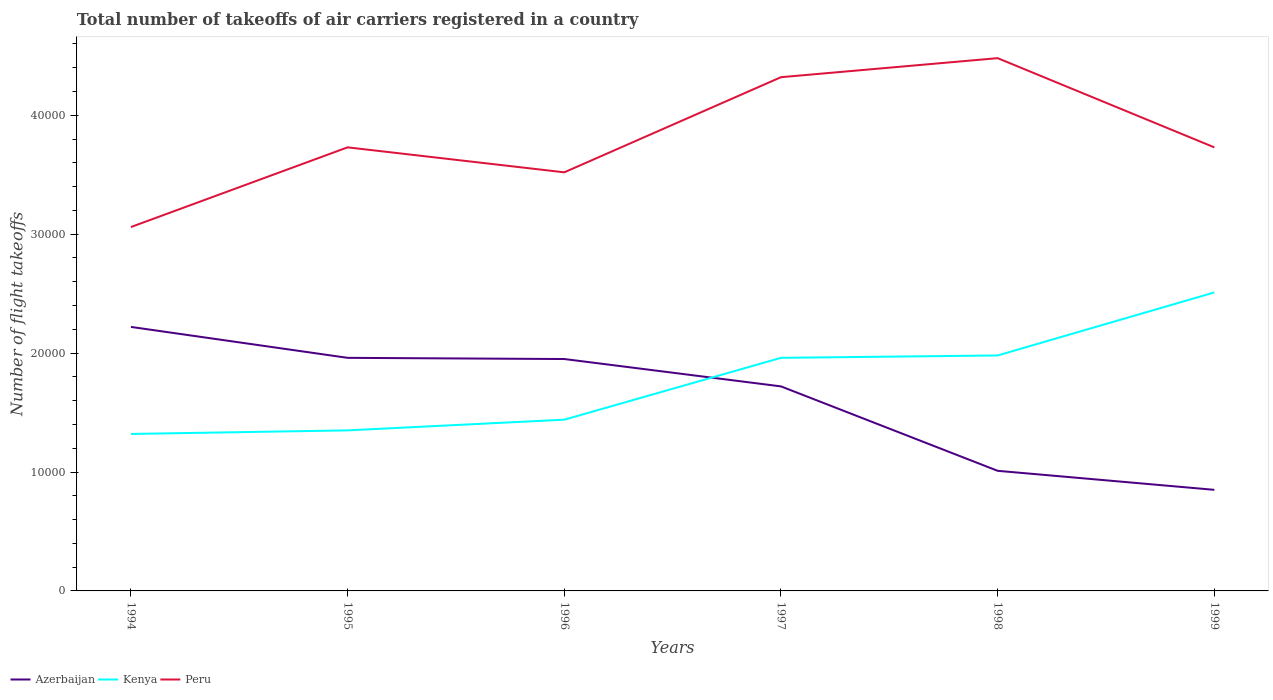Does the line corresponding to Azerbaijan intersect with the line corresponding to Kenya?
Ensure brevity in your answer.  Yes. Across all years, what is the maximum total number of flight takeoffs in Azerbaijan?
Offer a very short reply. 8500. What is the total total number of flight takeoffs in Kenya in the graph?
Ensure brevity in your answer.  -900. What is the difference between the highest and the second highest total number of flight takeoffs in Peru?
Keep it short and to the point. 1.42e+04. What is the difference between the highest and the lowest total number of flight takeoffs in Azerbaijan?
Your answer should be compact. 4. Is the total number of flight takeoffs in Azerbaijan strictly greater than the total number of flight takeoffs in Peru over the years?
Your answer should be compact. Yes. How many lines are there?
Your answer should be very brief. 3. How many years are there in the graph?
Your answer should be very brief. 6. Are the values on the major ticks of Y-axis written in scientific E-notation?
Offer a very short reply. No. What is the title of the graph?
Your response must be concise. Total number of takeoffs of air carriers registered in a country. Does "Montenegro" appear as one of the legend labels in the graph?
Your answer should be compact. No. What is the label or title of the Y-axis?
Your answer should be compact. Number of flight takeoffs. What is the Number of flight takeoffs in Azerbaijan in 1994?
Offer a very short reply. 2.22e+04. What is the Number of flight takeoffs in Kenya in 1994?
Your response must be concise. 1.32e+04. What is the Number of flight takeoffs in Peru in 1994?
Provide a succinct answer. 3.06e+04. What is the Number of flight takeoffs in Azerbaijan in 1995?
Your answer should be very brief. 1.96e+04. What is the Number of flight takeoffs in Kenya in 1995?
Your answer should be very brief. 1.35e+04. What is the Number of flight takeoffs of Peru in 1995?
Ensure brevity in your answer.  3.73e+04. What is the Number of flight takeoffs of Azerbaijan in 1996?
Keep it short and to the point. 1.95e+04. What is the Number of flight takeoffs of Kenya in 1996?
Make the answer very short. 1.44e+04. What is the Number of flight takeoffs of Peru in 1996?
Your response must be concise. 3.52e+04. What is the Number of flight takeoffs in Azerbaijan in 1997?
Your response must be concise. 1.72e+04. What is the Number of flight takeoffs of Kenya in 1997?
Keep it short and to the point. 1.96e+04. What is the Number of flight takeoffs in Peru in 1997?
Your response must be concise. 4.32e+04. What is the Number of flight takeoffs of Azerbaijan in 1998?
Ensure brevity in your answer.  1.01e+04. What is the Number of flight takeoffs in Kenya in 1998?
Your answer should be very brief. 1.98e+04. What is the Number of flight takeoffs in Peru in 1998?
Keep it short and to the point. 4.48e+04. What is the Number of flight takeoffs of Azerbaijan in 1999?
Offer a terse response. 8500. What is the Number of flight takeoffs in Kenya in 1999?
Ensure brevity in your answer.  2.51e+04. What is the Number of flight takeoffs of Peru in 1999?
Your response must be concise. 3.73e+04. Across all years, what is the maximum Number of flight takeoffs in Azerbaijan?
Give a very brief answer. 2.22e+04. Across all years, what is the maximum Number of flight takeoffs in Kenya?
Offer a terse response. 2.51e+04. Across all years, what is the maximum Number of flight takeoffs of Peru?
Your answer should be compact. 4.48e+04. Across all years, what is the minimum Number of flight takeoffs of Azerbaijan?
Ensure brevity in your answer.  8500. Across all years, what is the minimum Number of flight takeoffs of Kenya?
Your answer should be compact. 1.32e+04. Across all years, what is the minimum Number of flight takeoffs in Peru?
Provide a succinct answer. 3.06e+04. What is the total Number of flight takeoffs of Azerbaijan in the graph?
Provide a short and direct response. 9.71e+04. What is the total Number of flight takeoffs in Kenya in the graph?
Your response must be concise. 1.06e+05. What is the total Number of flight takeoffs in Peru in the graph?
Your answer should be very brief. 2.28e+05. What is the difference between the Number of flight takeoffs of Azerbaijan in 1994 and that in 1995?
Ensure brevity in your answer.  2600. What is the difference between the Number of flight takeoffs of Kenya in 1994 and that in 1995?
Make the answer very short. -300. What is the difference between the Number of flight takeoffs of Peru in 1994 and that in 1995?
Offer a very short reply. -6700. What is the difference between the Number of flight takeoffs in Azerbaijan in 1994 and that in 1996?
Offer a very short reply. 2700. What is the difference between the Number of flight takeoffs of Kenya in 1994 and that in 1996?
Your response must be concise. -1200. What is the difference between the Number of flight takeoffs of Peru in 1994 and that in 1996?
Your answer should be very brief. -4600. What is the difference between the Number of flight takeoffs in Kenya in 1994 and that in 1997?
Ensure brevity in your answer.  -6400. What is the difference between the Number of flight takeoffs in Peru in 1994 and that in 1997?
Your response must be concise. -1.26e+04. What is the difference between the Number of flight takeoffs of Azerbaijan in 1994 and that in 1998?
Keep it short and to the point. 1.21e+04. What is the difference between the Number of flight takeoffs of Kenya in 1994 and that in 1998?
Provide a short and direct response. -6600. What is the difference between the Number of flight takeoffs in Peru in 1994 and that in 1998?
Keep it short and to the point. -1.42e+04. What is the difference between the Number of flight takeoffs of Azerbaijan in 1994 and that in 1999?
Offer a very short reply. 1.37e+04. What is the difference between the Number of flight takeoffs of Kenya in 1994 and that in 1999?
Make the answer very short. -1.19e+04. What is the difference between the Number of flight takeoffs of Peru in 1994 and that in 1999?
Give a very brief answer. -6700. What is the difference between the Number of flight takeoffs in Kenya in 1995 and that in 1996?
Offer a terse response. -900. What is the difference between the Number of flight takeoffs of Peru in 1995 and that in 1996?
Provide a short and direct response. 2100. What is the difference between the Number of flight takeoffs in Azerbaijan in 1995 and that in 1997?
Your answer should be very brief. 2400. What is the difference between the Number of flight takeoffs in Kenya in 1995 and that in 1997?
Offer a terse response. -6100. What is the difference between the Number of flight takeoffs of Peru in 1995 and that in 1997?
Your response must be concise. -5900. What is the difference between the Number of flight takeoffs of Azerbaijan in 1995 and that in 1998?
Offer a terse response. 9500. What is the difference between the Number of flight takeoffs of Kenya in 1995 and that in 1998?
Offer a terse response. -6300. What is the difference between the Number of flight takeoffs of Peru in 1995 and that in 1998?
Offer a terse response. -7500. What is the difference between the Number of flight takeoffs of Azerbaijan in 1995 and that in 1999?
Make the answer very short. 1.11e+04. What is the difference between the Number of flight takeoffs of Kenya in 1995 and that in 1999?
Offer a very short reply. -1.16e+04. What is the difference between the Number of flight takeoffs in Peru in 1995 and that in 1999?
Your response must be concise. 0. What is the difference between the Number of flight takeoffs of Azerbaijan in 1996 and that in 1997?
Keep it short and to the point. 2300. What is the difference between the Number of flight takeoffs of Kenya in 1996 and that in 1997?
Provide a succinct answer. -5200. What is the difference between the Number of flight takeoffs in Peru in 1996 and that in 1997?
Provide a succinct answer. -8000. What is the difference between the Number of flight takeoffs of Azerbaijan in 1996 and that in 1998?
Your answer should be very brief. 9400. What is the difference between the Number of flight takeoffs of Kenya in 1996 and that in 1998?
Give a very brief answer. -5400. What is the difference between the Number of flight takeoffs of Peru in 1996 and that in 1998?
Your response must be concise. -9600. What is the difference between the Number of flight takeoffs in Azerbaijan in 1996 and that in 1999?
Provide a short and direct response. 1.10e+04. What is the difference between the Number of flight takeoffs of Kenya in 1996 and that in 1999?
Keep it short and to the point. -1.07e+04. What is the difference between the Number of flight takeoffs in Peru in 1996 and that in 1999?
Provide a succinct answer. -2100. What is the difference between the Number of flight takeoffs in Azerbaijan in 1997 and that in 1998?
Ensure brevity in your answer.  7100. What is the difference between the Number of flight takeoffs of Kenya in 1997 and that in 1998?
Your answer should be compact. -200. What is the difference between the Number of flight takeoffs of Peru in 1997 and that in 1998?
Offer a terse response. -1600. What is the difference between the Number of flight takeoffs of Azerbaijan in 1997 and that in 1999?
Give a very brief answer. 8700. What is the difference between the Number of flight takeoffs in Kenya in 1997 and that in 1999?
Provide a short and direct response. -5500. What is the difference between the Number of flight takeoffs in Peru in 1997 and that in 1999?
Make the answer very short. 5900. What is the difference between the Number of flight takeoffs in Azerbaijan in 1998 and that in 1999?
Your answer should be compact. 1600. What is the difference between the Number of flight takeoffs in Kenya in 1998 and that in 1999?
Give a very brief answer. -5300. What is the difference between the Number of flight takeoffs of Peru in 1998 and that in 1999?
Provide a short and direct response. 7500. What is the difference between the Number of flight takeoffs of Azerbaijan in 1994 and the Number of flight takeoffs of Kenya in 1995?
Your answer should be very brief. 8700. What is the difference between the Number of flight takeoffs of Azerbaijan in 1994 and the Number of flight takeoffs of Peru in 1995?
Offer a very short reply. -1.51e+04. What is the difference between the Number of flight takeoffs of Kenya in 1994 and the Number of flight takeoffs of Peru in 1995?
Offer a very short reply. -2.41e+04. What is the difference between the Number of flight takeoffs in Azerbaijan in 1994 and the Number of flight takeoffs in Kenya in 1996?
Keep it short and to the point. 7800. What is the difference between the Number of flight takeoffs of Azerbaijan in 1994 and the Number of flight takeoffs of Peru in 1996?
Your response must be concise. -1.30e+04. What is the difference between the Number of flight takeoffs in Kenya in 1994 and the Number of flight takeoffs in Peru in 1996?
Keep it short and to the point. -2.20e+04. What is the difference between the Number of flight takeoffs of Azerbaijan in 1994 and the Number of flight takeoffs of Kenya in 1997?
Ensure brevity in your answer.  2600. What is the difference between the Number of flight takeoffs of Azerbaijan in 1994 and the Number of flight takeoffs of Peru in 1997?
Ensure brevity in your answer.  -2.10e+04. What is the difference between the Number of flight takeoffs in Kenya in 1994 and the Number of flight takeoffs in Peru in 1997?
Provide a succinct answer. -3.00e+04. What is the difference between the Number of flight takeoffs in Azerbaijan in 1994 and the Number of flight takeoffs in Kenya in 1998?
Provide a short and direct response. 2400. What is the difference between the Number of flight takeoffs of Azerbaijan in 1994 and the Number of flight takeoffs of Peru in 1998?
Ensure brevity in your answer.  -2.26e+04. What is the difference between the Number of flight takeoffs in Kenya in 1994 and the Number of flight takeoffs in Peru in 1998?
Provide a succinct answer. -3.16e+04. What is the difference between the Number of flight takeoffs of Azerbaijan in 1994 and the Number of flight takeoffs of Kenya in 1999?
Your answer should be very brief. -2900. What is the difference between the Number of flight takeoffs in Azerbaijan in 1994 and the Number of flight takeoffs in Peru in 1999?
Keep it short and to the point. -1.51e+04. What is the difference between the Number of flight takeoffs in Kenya in 1994 and the Number of flight takeoffs in Peru in 1999?
Provide a succinct answer. -2.41e+04. What is the difference between the Number of flight takeoffs in Azerbaijan in 1995 and the Number of flight takeoffs in Kenya in 1996?
Ensure brevity in your answer.  5200. What is the difference between the Number of flight takeoffs in Azerbaijan in 1995 and the Number of flight takeoffs in Peru in 1996?
Your answer should be compact. -1.56e+04. What is the difference between the Number of flight takeoffs of Kenya in 1995 and the Number of flight takeoffs of Peru in 1996?
Keep it short and to the point. -2.17e+04. What is the difference between the Number of flight takeoffs of Azerbaijan in 1995 and the Number of flight takeoffs of Peru in 1997?
Your answer should be very brief. -2.36e+04. What is the difference between the Number of flight takeoffs in Kenya in 1995 and the Number of flight takeoffs in Peru in 1997?
Keep it short and to the point. -2.97e+04. What is the difference between the Number of flight takeoffs in Azerbaijan in 1995 and the Number of flight takeoffs in Kenya in 1998?
Offer a terse response. -200. What is the difference between the Number of flight takeoffs in Azerbaijan in 1995 and the Number of flight takeoffs in Peru in 1998?
Give a very brief answer. -2.52e+04. What is the difference between the Number of flight takeoffs in Kenya in 1995 and the Number of flight takeoffs in Peru in 1998?
Offer a terse response. -3.13e+04. What is the difference between the Number of flight takeoffs in Azerbaijan in 1995 and the Number of flight takeoffs in Kenya in 1999?
Make the answer very short. -5500. What is the difference between the Number of flight takeoffs of Azerbaijan in 1995 and the Number of flight takeoffs of Peru in 1999?
Your response must be concise. -1.77e+04. What is the difference between the Number of flight takeoffs of Kenya in 1995 and the Number of flight takeoffs of Peru in 1999?
Offer a very short reply. -2.38e+04. What is the difference between the Number of flight takeoffs of Azerbaijan in 1996 and the Number of flight takeoffs of Kenya in 1997?
Ensure brevity in your answer.  -100. What is the difference between the Number of flight takeoffs of Azerbaijan in 1996 and the Number of flight takeoffs of Peru in 1997?
Make the answer very short. -2.37e+04. What is the difference between the Number of flight takeoffs of Kenya in 1996 and the Number of flight takeoffs of Peru in 1997?
Your response must be concise. -2.88e+04. What is the difference between the Number of flight takeoffs in Azerbaijan in 1996 and the Number of flight takeoffs in Kenya in 1998?
Offer a very short reply. -300. What is the difference between the Number of flight takeoffs of Azerbaijan in 1996 and the Number of flight takeoffs of Peru in 1998?
Your response must be concise. -2.53e+04. What is the difference between the Number of flight takeoffs of Kenya in 1996 and the Number of flight takeoffs of Peru in 1998?
Provide a short and direct response. -3.04e+04. What is the difference between the Number of flight takeoffs of Azerbaijan in 1996 and the Number of flight takeoffs of Kenya in 1999?
Your response must be concise. -5600. What is the difference between the Number of flight takeoffs in Azerbaijan in 1996 and the Number of flight takeoffs in Peru in 1999?
Offer a terse response. -1.78e+04. What is the difference between the Number of flight takeoffs of Kenya in 1996 and the Number of flight takeoffs of Peru in 1999?
Provide a short and direct response. -2.29e+04. What is the difference between the Number of flight takeoffs in Azerbaijan in 1997 and the Number of flight takeoffs in Kenya in 1998?
Your answer should be very brief. -2600. What is the difference between the Number of flight takeoffs of Azerbaijan in 1997 and the Number of flight takeoffs of Peru in 1998?
Give a very brief answer. -2.76e+04. What is the difference between the Number of flight takeoffs of Kenya in 1997 and the Number of flight takeoffs of Peru in 1998?
Give a very brief answer. -2.52e+04. What is the difference between the Number of flight takeoffs in Azerbaijan in 1997 and the Number of flight takeoffs in Kenya in 1999?
Make the answer very short. -7900. What is the difference between the Number of flight takeoffs in Azerbaijan in 1997 and the Number of flight takeoffs in Peru in 1999?
Make the answer very short. -2.01e+04. What is the difference between the Number of flight takeoffs in Kenya in 1997 and the Number of flight takeoffs in Peru in 1999?
Keep it short and to the point. -1.77e+04. What is the difference between the Number of flight takeoffs of Azerbaijan in 1998 and the Number of flight takeoffs of Kenya in 1999?
Your answer should be very brief. -1.50e+04. What is the difference between the Number of flight takeoffs in Azerbaijan in 1998 and the Number of flight takeoffs in Peru in 1999?
Your answer should be very brief. -2.72e+04. What is the difference between the Number of flight takeoffs in Kenya in 1998 and the Number of flight takeoffs in Peru in 1999?
Your response must be concise. -1.75e+04. What is the average Number of flight takeoffs of Azerbaijan per year?
Your response must be concise. 1.62e+04. What is the average Number of flight takeoffs in Kenya per year?
Provide a succinct answer. 1.76e+04. What is the average Number of flight takeoffs of Peru per year?
Your answer should be compact. 3.81e+04. In the year 1994, what is the difference between the Number of flight takeoffs in Azerbaijan and Number of flight takeoffs in Kenya?
Give a very brief answer. 9000. In the year 1994, what is the difference between the Number of flight takeoffs in Azerbaijan and Number of flight takeoffs in Peru?
Your answer should be very brief. -8400. In the year 1994, what is the difference between the Number of flight takeoffs of Kenya and Number of flight takeoffs of Peru?
Offer a terse response. -1.74e+04. In the year 1995, what is the difference between the Number of flight takeoffs in Azerbaijan and Number of flight takeoffs in Kenya?
Offer a terse response. 6100. In the year 1995, what is the difference between the Number of flight takeoffs of Azerbaijan and Number of flight takeoffs of Peru?
Provide a succinct answer. -1.77e+04. In the year 1995, what is the difference between the Number of flight takeoffs in Kenya and Number of flight takeoffs in Peru?
Your response must be concise. -2.38e+04. In the year 1996, what is the difference between the Number of flight takeoffs of Azerbaijan and Number of flight takeoffs of Kenya?
Your answer should be very brief. 5100. In the year 1996, what is the difference between the Number of flight takeoffs in Azerbaijan and Number of flight takeoffs in Peru?
Your answer should be compact. -1.57e+04. In the year 1996, what is the difference between the Number of flight takeoffs of Kenya and Number of flight takeoffs of Peru?
Ensure brevity in your answer.  -2.08e+04. In the year 1997, what is the difference between the Number of flight takeoffs in Azerbaijan and Number of flight takeoffs in Kenya?
Keep it short and to the point. -2400. In the year 1997, what is the difference between the Number of flight takeoffs of Azerbaijan and Number of flight takeoffs of Peru?
Your response must be concise. -2.60e+04. In the year 1997, what is the difference between the Number of flight takeoffs in Kenya and Number of flight takeoffs in Peru?
Provide a succinct answer. -2.36e+04. In the year 1998, what is the difference between the Number of flight takeoffs of Azerbaijan and Number of flight takeoffs of Kenya?
Ensure brevity in your answer.  -9700. In the year 1998, what is the difference between the Number of flight takeoffs in Azerbaijan and Number of flight takeoffs in Peru?
Offer a very short reply. -3.47e+04. In the year 1998, what is the difference between the Number of flight takeoffs of Kenya and Number of flight takeoffs of Peru?
Ensure brevity in your answer.  -2.50e+04. In the year 1999, what is the difference between the Number of flight takeoffs in Azerbaijan and Number of flight takeoffs in Kenya?
Your answer should be compact. -1.66e+04. In the year 1999, what is the difference between the Number of flight takeoffs in Azerbaijan and Number of flight takeoffs in Peru?
Offer a terse response. -2.88e+04. In the year 1999, what is the difference between the Number of flight takeoffs in Kenya and Number of flight takeoffs in Peru?
Offer a terse response. -1.22e+04. What is the ratio of the Number of flight takeoffs of Azerbaijan in 1994 to that in 1995?
Provide a short and direct response. 1.13. What is the ratio of the Number of flight takeoffs in Kenya in 1994 to that in 1995?
Your answer should be very brief. 0.98. What is the ratio of the Number of flight takeoffs in Peru in 1994 to that in 1995?
Your answer should be compact. 0.82. What is the ratio of the Number of flight takeoffs in Azerbaijan in 1994 to that in 1996?
Provide a succinct answer. 1.14. What is the ratio of the Number of flight takeoffs of Peru in 1994 to that in 1996?
Offer a terse response. 0.87. What is the ratio of the Number of flight takeoffs of Azerbaijan in 1994 to that in 1997?
Keep it short and to the point. 1.29. What is the ratio of the Number of flight takeoffs in Kenya in 1994 to that in 1997?
Offer a terse response. 0.67. What is the ratio of the Number of flight takeoffs in Peru in 1994 to that in 1997?
Keep it short and to the point. 0.71. What is the ratio of the Number of flight takeoffs of Azerbaijan in 1994 to that in 1998?
Provide a succinct answer. 2.2. What is the ratio of the Number of flight takeoffs in Kenya in 1994 to that in 1998?
Keep it short and to the point. 0.67. What is the ratio of the Number of flight takeoffs of Peru in 1994 to that in 1998?
Your answer should be compact. 0.68. What is the ratio of the Number of flight takeoffs in Azerbaijan in 1994 to that in 1999?
Keep it short and to the point. 2.61. What is the ratio of the Number of flight takeoffs of Kenya in 1994 to that in 1999?
Your answer should be compact. 0.53. What is the ratio of the Number of flight takeoffs of Peru in 1994 to that in 1999?
Keep it short and to the point. 0.82. What is the ratio of the Number of flight takeoffs in Peru in 1995 to that in 1996?
Your response must be concise. 1.06. What is the ratio of the Number of flight takeoffs of Azerbaijan in 1995 to that in 1997?
Provide a short and direct response. 1.14. What is the ratio of the Number of flight takeoffs in Kenya in 1995 to that in 1997?
Provide a succinct answer. 0.69. What is the ratio of the Number of flight takeoffs of Peru in 1995 to that in 1997?
Your answer should be very brief. 0.86. What is the ratio of the Number of flight takeoffs of Azerbaijan in 1995 to that in 1998?
Ensure brevity in your answer.  1.94. What is the ratio of the Number of flight takeoffs of Kenya in 1995 to that in 1998?
Make the answer very short. 0.68. What is the ratio of the Number of flight takeoffs in Peru in 1995 to that in 1998?
Provide a short and direct response. 0.83. What is the ratio of the Number of flight takeoffs of Azerbaijan in 1995 to that in 1999?
Make the answer very short. 2.31. What is the ratio of the Number of flight takeoffs in Kenya in 1995 to that in 1999?
Offer a very short reply. 0.54. What is the ratio of the Number of flight takeoffs of Peru in 1995 to that in 1999?
Provide a succinct answer. 1. What is the ratio of the Number of flight takeoffs of Azerbaijan in 1996 to that in 1997?
Give a very brief answer. 1.13. What is the ratio of the Number of flight takeoffs in Kenya in 1996 to that in 1997?
Your response must be concise. 0.73. What is the ratio of the Number of flight takeoffs of Peru in 1996 to that in 1997?
Your answer should be very brief. 0.81. What is the ratio of the Number of flight takeoffs in Azerbaijan in 1996 to that in 1998?
Your response must be concise. 1.93. What is the ratio of the Number of flight takeoffs of Kenya in 1996 to that in 1998?
Offer a very short reply. 0.73. What is the ratio of the Number of flight takeoffs of Peru in 1996 to that in 1998?
Ensure brevity in your answer.  0.79. What is the ratio of the Number of flight takeoffs in Azerbaijan in 1996 to that in 1999?
Offer a terse response. 2.29. What is the ratio of the Number of flight takeoffs in Kenya in 1996 to that in 1999?
Keep it short and to the point. 0.57. What is the ratio of the Number of flight takeoffs in Peru in 1996 to that in 1999?
Keep it short and to the point. 0.94. What is the ratio of the Number of flight takeoffs in Azerbaijan in 1997 to that in 1998?
Make the answer very short. 1.7. What is the ratio of the Number of flight takeoffs in Azerbaijan in 1997 to that in 1999?
Your response must be concise. 2.02. What is the ratio of the Number of flight takeoffs of Kenya in 1997 to that in 1999?
Provide a short and direct response. 0.78. What is the ratio of the Number of flight takeoffs in Peru in 1997 to that in 1999?
Give a very brief answer. 1.16. What is the ratio of the Number of flight takeoffs in Azerbaijan in 1998 to that in 1999?
Give a very brief answer. 1.19. What is the ratio of the Number of flight takeoffs in Kenya in 1998 to that in 1999?
Make the answer very short. 0.79. What is the ratio of the Number of flight takeoffs of Peru in 1998 to that in 1999?
Ensure brevity in your answer.  1.2. What is the difference between the highest and the second highest Number of flight takeoffs of Azerbaijan?
Ensure brevity in your answer.  2600. What is the difference between the highest and the second highest Number of flight takeoffs in Kenya?
Provide a succinct answer. 5300. What is the difference between the highest and the second highest Number of flight takeoffs in Peru?
Make the answer very short. 1600. What is the difference between the highest and the lowest Number of flight takeoffs of Azerbaijan?
Provide a succinct answer. 1.37e+04. What is the difference between the highest and the lowest Number of flight takeoffs of Kenya?
Give a very brief answer. 1.19e+04. What is the difference between the highest and the lowest Number of flight takeoffs in Peru?
Give a very brief answer. 1.42e+04. 